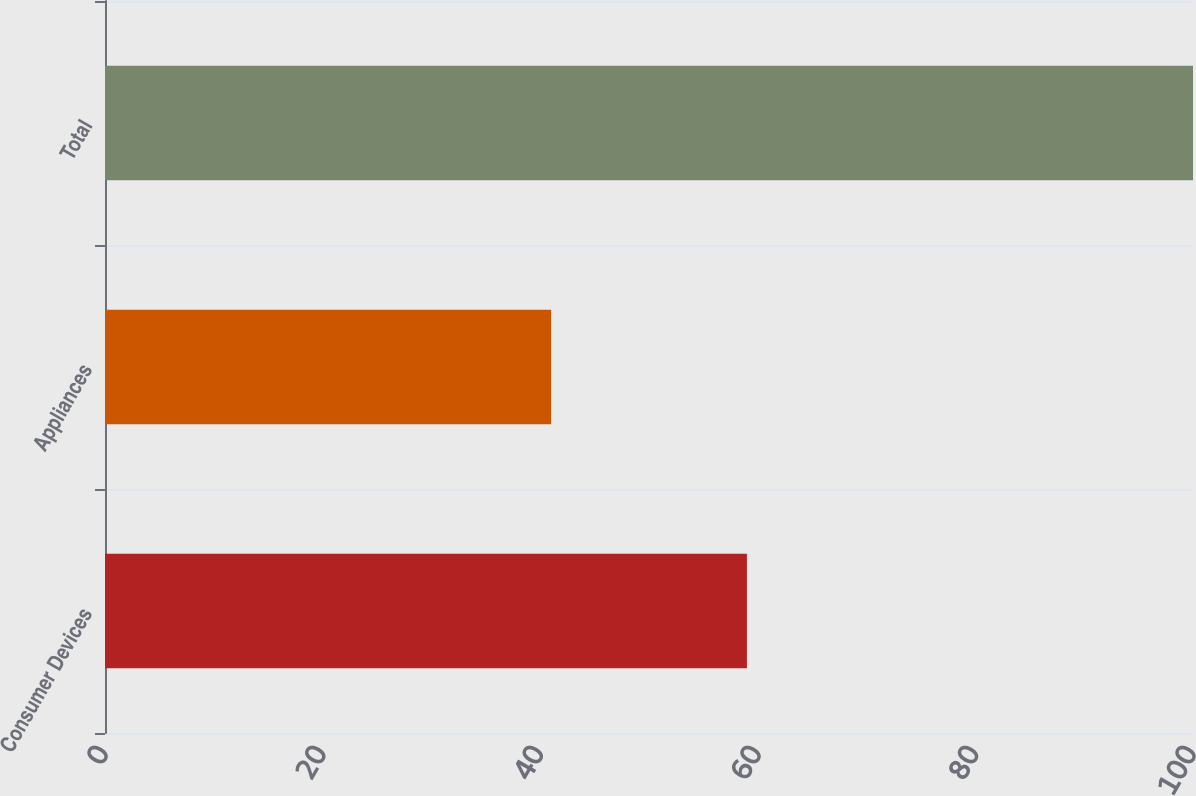Convert chart to OTSL. <chart><loc_0><loc_0><loc_500><loc_500><bar_chart><fcel>Consumer Devices<fcel>Appliances<fcel>Total<nl><fcel>59<fcel>41<fcel>100<nl></chart> 